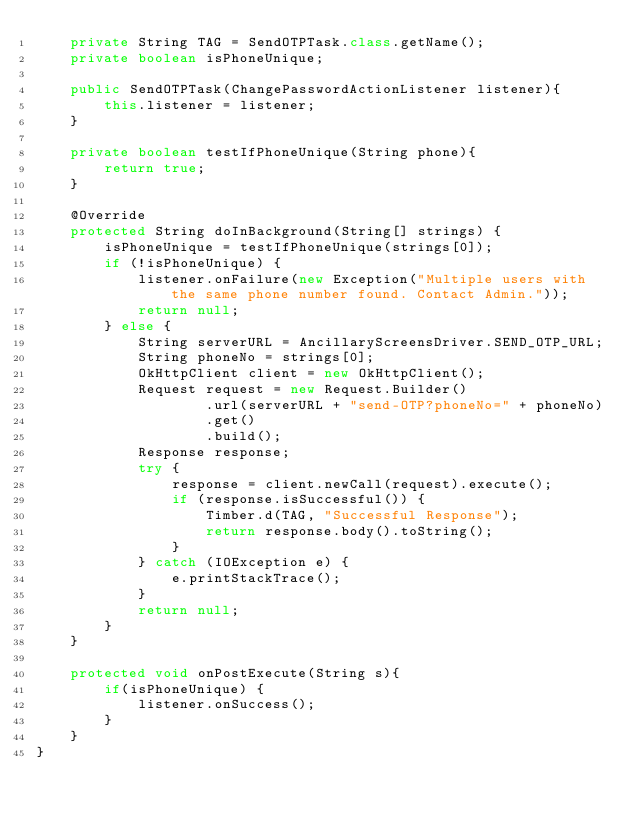Convert code to text. <code><loc_0><loc_0><loc_500><loc_500><_Java_>    private String TAG = SendOTPTask.class.getName();
    private boolean isPhoneUnique;

    public SendOTPTask(ChangePasswordActionListener listener){
        this.listener = listener;
    }

    private boolean testIfPhoneUnique(String phone){
        return true;
    }

    @Override
    protected String doInBackground(String[] strings) {
        isPhoneUnique = testIfPhoneUnique(strings[0]);
        if (!isPhoneUnique) {
            listener.onFailure(new Exception("Multiple users with the same phone number found. Contact Admin."));
            return null;
        } else {
            String serverURL = AncillaryScreensDriver.SEND_OTP_URL;
            String phoneNo = strings[0];
            OkHttpClient client = new OkHttpClient();
            Request request = new Request.Builder()
                    .url(serverURL + "send-OTP?phoneNo=" + phoneNo)
                    .get()
                    .build();
            Response response;
            try {
                response = client.newCall(request).execute();
                if (response.isSuccessful()) {
                    Timber.d(TAG, "Successful Response");
                    return response.body().toString();
                }
            } catch (IOException e) {
                e.printStackTrace();
            }
            return null;
        }
    }

    protected void onPostExecute(String s){
        if(isPhoneUnique) {
            listener.onSuccess();
        }
    }
}
</code> 